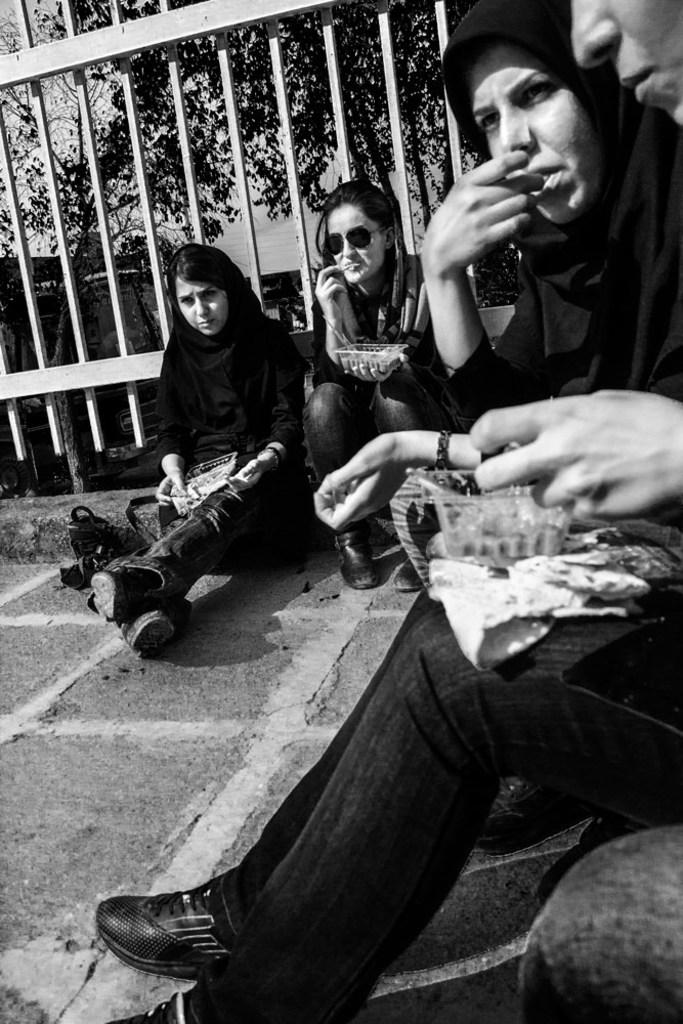What are the people in the image doing? There is a group of people sitting in the image. What can be seen in the background of the image? There is railing and trees visible in the background of the image. How is the image presented? The image is in black and white. How does the error affect the people sitting in the image? There is no error present in the image; it is a group of people sitting. What type of boundary is visible in the image? There is no specific boundary mentioned in the facts; only railing is visible in the background. 